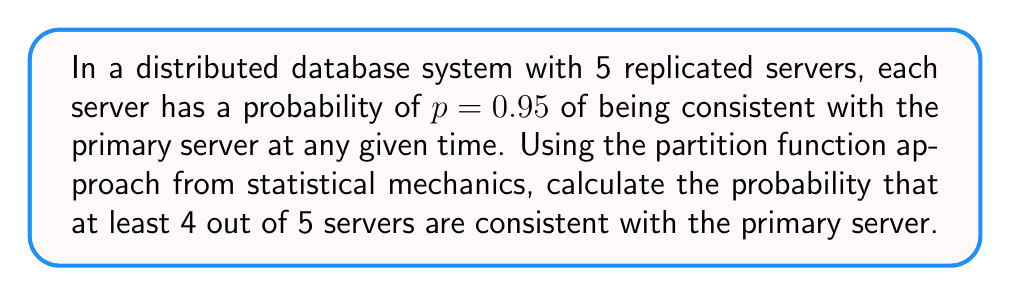Help me with this question. To solve this problem, we'll use the partition function approach from statistical mechanics:

1. Define the microstate: Each server can be in one of two states (consistent or inconsistent).

2. Calculate the partition function $Z$:
   $$Z = \sum_{i=0}^{5} {5 \choose i} p^i (1-p)^{5-i}$$
   
   This sum represents all possible configurations of the system.

3. Calculate the probability of at least 4 servers being consistent:
   $$P(\text{at least 4 consistent}) = \frac{{5 \choose 4}p^4(1-p)^1 + {5 \choose 5}p^5(1-p)^0}{Z}$$

4. Substitute the values:
   $$P = \frac{{5 \choose 4}(0.95)^4(0.05)^1 + {5 \choose 5}(0.95)^5(0.05)^0}{{5 \choose 0}(0.95)^0(0.05)^5 + {5 \choose 1}(0.95)^1(0.05)^4 + {5 \choose 2}(0.95)^2(0.05)^3 + {5 \choose 3}(0.95)^3(0.05)^2 + {5 \choose 4}(0.95)^4(0.05)^1 + {5 \choose 5}(0.95)^5(0.05)^0}$$

5. Calculate the numerator and denominator:
   Numerator = 5 * 0.95^4 * 0.05 + 0.95^5 = 0.817125
   Denominator = 0.0000003125 + 0.0000237500 + 0.0006768750 + 0.0096187500 + 0.0815812500 + 0.7737809375 = 0.8656818750

6. Divide the numerator by the denominator:
   $$P = \frac{0.817125}{0.8656818750} \approx 0.9440$$
Answer: 0.9440 